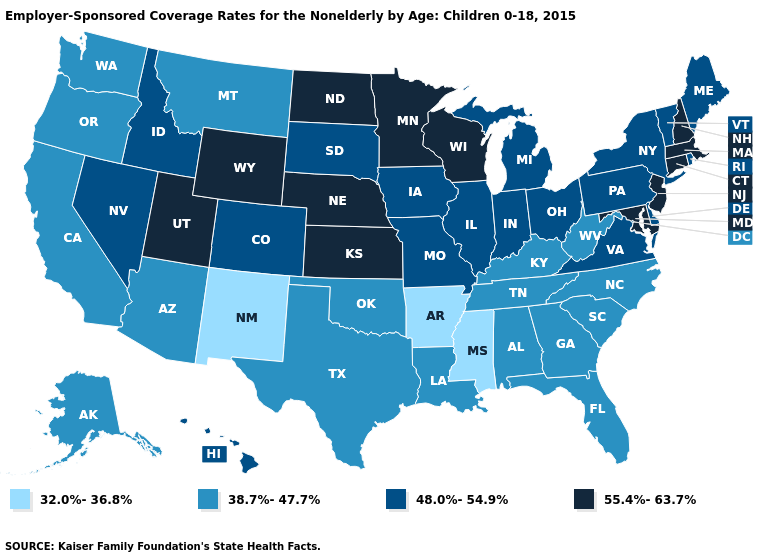Does New Mexico have the lowest value in the USA?
Short answer required. Yes. Does Maryland have the same value as Nevada?
Short answer required. No. What is the highest value in the South ?
Write a very short answer. 55.4%-63.7%. Does Alaska have a lower value than Minnesota?
Quick response, please. Yes. What is the value of Pennsylvania?
Write a very short answer. 48.0%-54.9%. Name the states that have a value in the range 48.0%-54.9%?
Short answer required. Colorado, Delaware, Hawaii, Idaho, Illinois, Indiana, Iowa, Maine, Michigan, Missouri, Nevada, New York, Ohio, Pennsylvania, Rhode Island, South Dakota, Vermont, Virginia. Does Maine have a higher value than Georgia?
Quick response, please. Yes. Does Mississippi have the lowest value in the USA?
Answer briefly. Yes. What is the value of Minnesota?
Short answer required. 55.4%-63.7%. Among the states that border Tennessee , which have the lowest value?
Keep it brief. Arkansas, Mississippi. Name the states that have a value in the range 48.0%-54.9%?
Concise answer only. Colorado, Delaware, Hawaii, Idaho, Illinois, Indiana, Iowa, Maine, Michigan, Missouri, Nevada, New York, Ohio, Pennsylvania, Rhode Island, South Dakota, Vermont, Virginia. What is the value of Arizona?
Short answer required. 38.7%-47.7%. What is the highest value in states that border Utah?
Write a very short answer. 55.4%-63.7%. Does Mississippi have the lowest value in the USA?
Keep it brief. Yes. Name the states that have a value in the range 48.0%-54.9%?
Write a very short answer. Colorado, Delaware, Hawaii, Idaho, Illinois, Indiana, Iowa, Maine, Michigan, Missouri, Nevada, New York, Ohio, Pennsylvania, Rhode Island, South Dakota, Vermont, Virginia. 